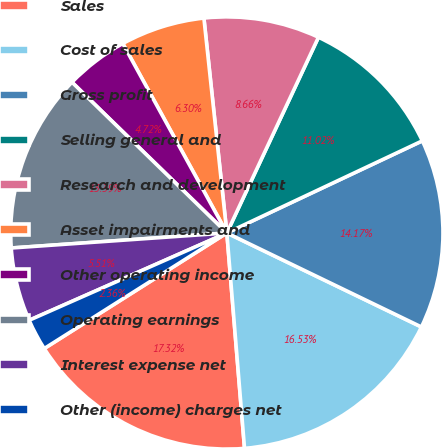<chart> <loc_0><loc_0><loc_500><loc_500><pie_chart><fcel>Sales<fcel>Cost of sales<fcel>Gross profit<fcel>Selling general and<fcel>Research and development<fcel>Asset impairments and<fcel>Other operating income<fcel>Operating earnings<fcel>Interest expense net<fcel>Other (income) charges net<nl><fcel>17.32%<fcel>16.53%<fcel>14.17%<fcel>11.02%<fcel>8.66%<fcel>6.3%<fcel>4.72%<fcel>13.39%<fcel>5.51%<fcel>2.36%<nl></chart> 